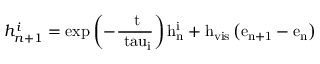Convert formula to latex. <formula><loc_0><loc_0><loc_500><loc_500>h _ { n + 1 } ^ { i } = { e x p } \left ( - \frac { \Delta t } { \ t a u _ { i } } \right ) h _ { n } ^ { i } + h _ { v i s } \left ( e _ { n + 1 } - e _ { n } \right )</formula> 